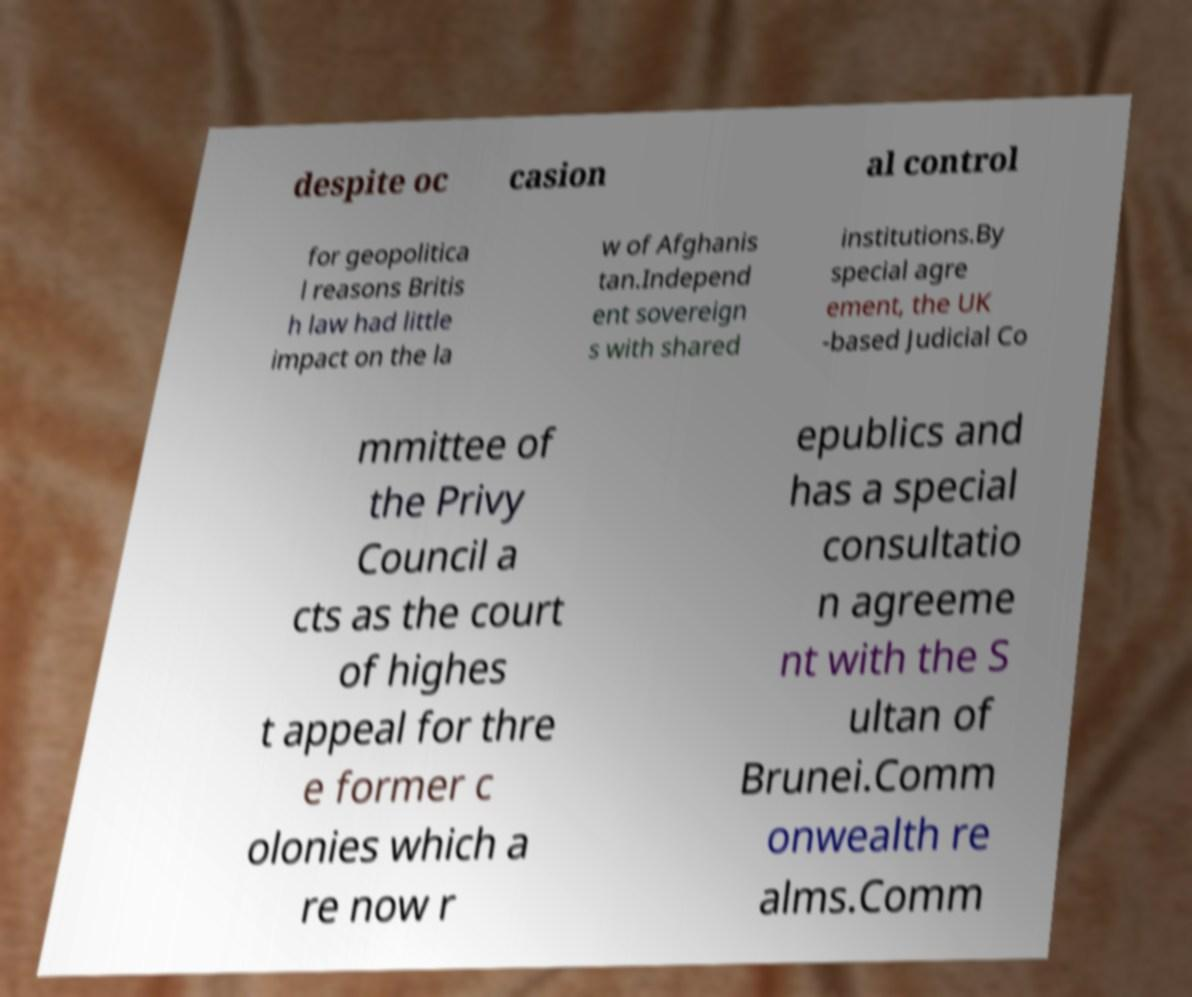What messages or text are displayed in this image? I need them in a readable, typed format. despite oc casion al control for geopolitica l reasons Britis h law had little impact on the la w of Afghanis tan.Independ ent sovereign s with shared institutions.By special agre ement, the UK -based Judicial Co mmittee of the Privy Council a cts as the court of highes t appeal for thre e former c olonies which a re now r epublics and has a special consultatio n agreeme nt with the S ultan of Brunei.Comm onwealth re alms.Comm 